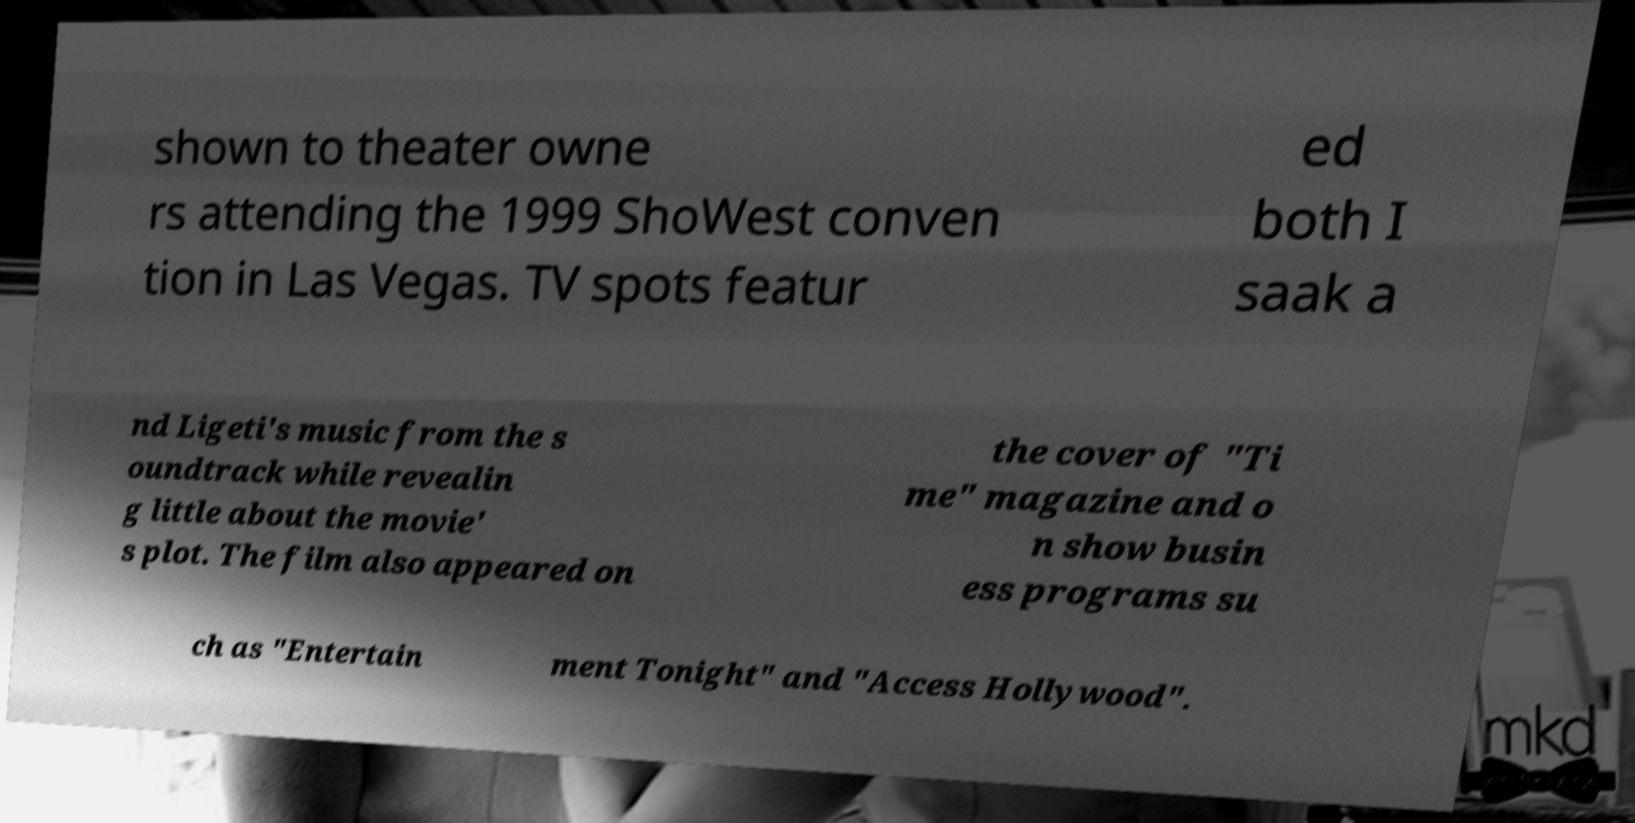There's text embedded in this image that I need extracted. Can you transcribe it verbatim? shown to theater owne rs attending the 1999 ShoWest conven tion in Las Vegas. TV spots featur ed both I saak a nd Ligeti's music from the s oundtrack while revealin g little about the movie' s plot. The film also appeared on the cover of "Ti me" magazine and o n show busin ess programs su ch as "Entertain ment Tonight" and "Access Hollywood". 